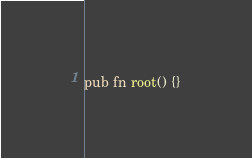<code> <loc_0><loc_0><loc_500><loc_500><_Rust_>pub fn root() {}
</code> 